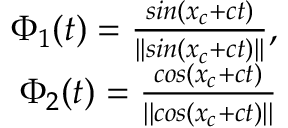<formula> <loc_0><loc_0><loc_500><loc_500>\begin{array} { r } { \Phi _ { 1 } ( t ) = \frac { \sin ( x _ { c } + c t ) } { | | \sin ( x _ { c } + c t ) | | } , } \\ { \Phi _ { 2 } ( t ) = \frac { \cos ( x _ { c } + c t ) } { | | \cos ( x _ { c } + c t ) | | } } \end{array}</formula> 